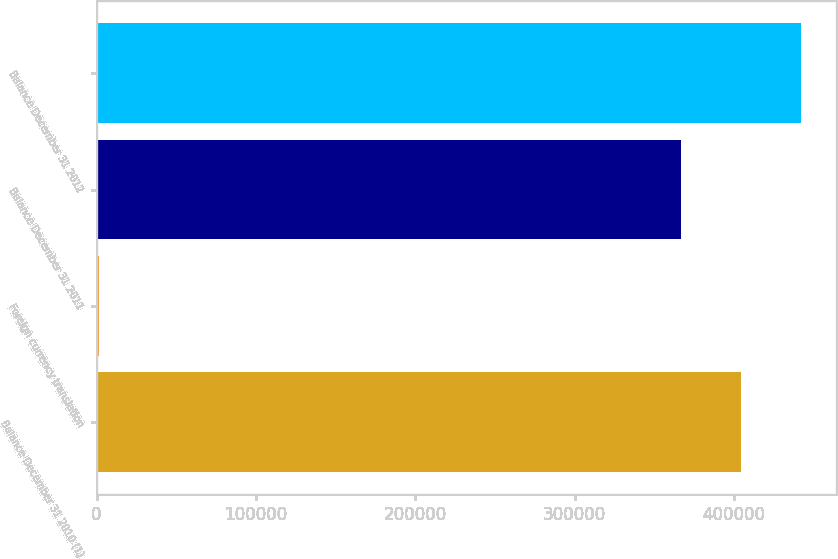Convert chart. <chart><loc_0><loc_0><loc_500><loc_500><bar_chart><fcel>Balance December 31 2010 (1)<fcel>Foreign currency translation<fcel>Balance December 31 2011<fcel>Balance December 31 2012<nl><fcel>404548<fcel>1541<fcel>366980<fcel>442117<nl></chart> 